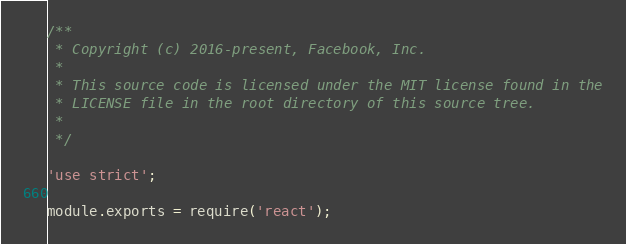Convert code to text. <code><loc_0><loc_0><loc_500><loc_500><_JavaScript_>/**
 * Copyright (c) 2016-present, Facebook, Inc.
 *
 * This source code is licensed under the MIT license found in the
 * LICENSE file in the root directory of this source tree.
 *
 */

'use strict';

module.exports = require('react');
</code> 